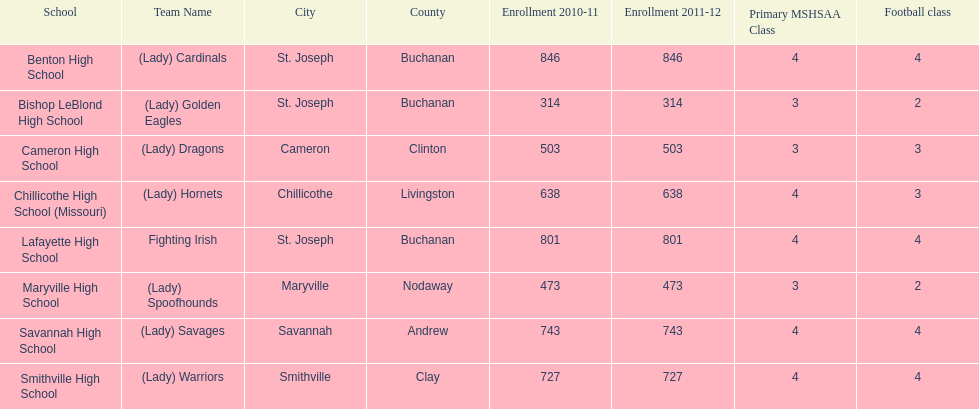What school has 3 football classes but only has 638 student enrollment? Chillicothe High School (Missouri). 